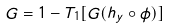<formula> <loc_0><loc_0><loc_500><loc_500>G = 1 - T _ { 1 } [ G ( h _ { y } \circ \phi ) ]</formula> 